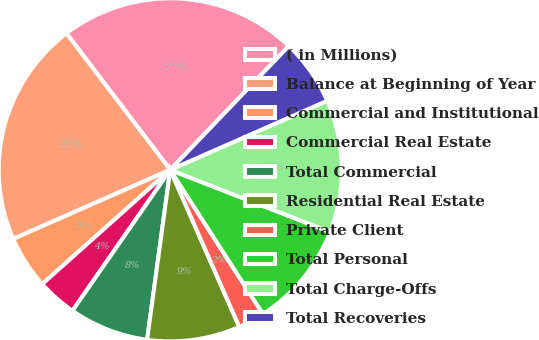Convert chart to OTSL. <chart><loc_0><loc_0><loc_500><loc_500><pie_chart><fcel>( in Millions)<fcel>Balance at Beginning of Year<fcel>Commercial and Institutional<fcel>Commercial Real Estate<fcel>Total Commercial<fcel>Residential Real Estate<fcel>Private Client<fcel>Total Personal<fcel>Total Charge-Offs<fcel>Total Recoveries<nl><fcel>22.5%<fcel>21.25%<fcel>5.0%<fcel>3.75%<fcel>7.5%<fcel>8.75%<fcel>2.5%<fcel>10.0%<fcel>12.5%<fcel>6.25%<nl></chart> 